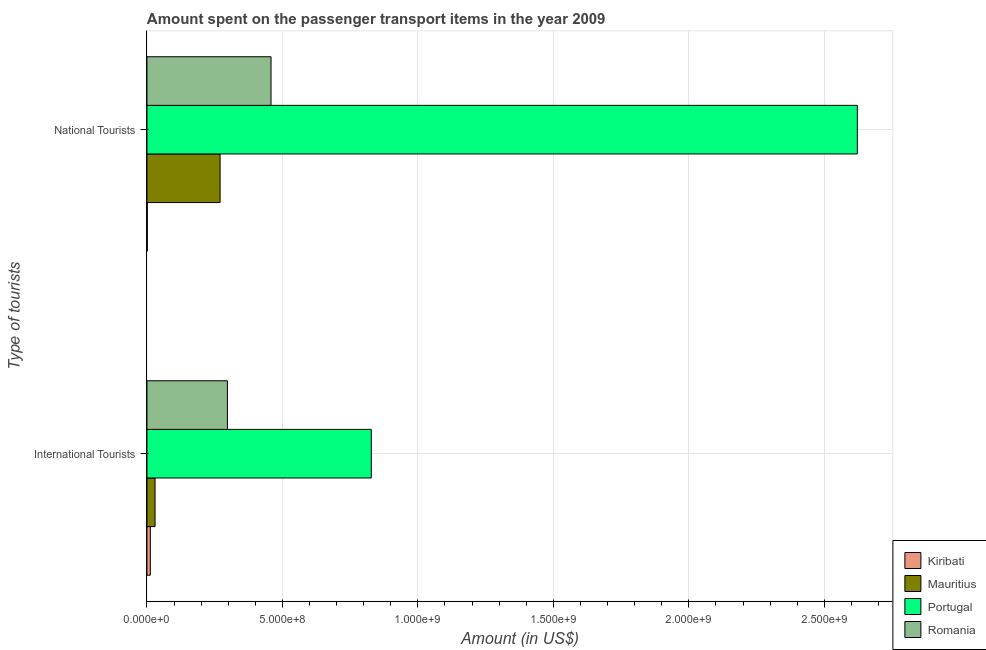Are the number of bars per tick equal to the number of legend labels?
Offer a very short reply. Yes. Are the number of bars on each tick of the Y-axis equal?
Keep it short and to the point. Yes. How many bars are there on the 1st tick from the bottom?
Ensure brevity in your answer.  4. What is the label of the 1st group of bars from the top?
Your response must be concise. National Tourists. What is the amount spent on transport items of international tourists in Mauritius?
Your response must be concise. 3.00e+07. Across all countries, what is the maximum amount spent on transport items of national tourists?
Give a very brief answer. 2.62e+09. Across all countries, what is the minimum amount spent on transport items of national tourists?
Give a very brief answer. 1.30e+06. In which country was the amount spent on transport items of national tourists minimum?
Offer a terse response. Kiribati. What is the total amount spent on transport items of international tourists in the graph?
Your answer should be very brief. 1.17e+09. What is the difference between the amount spent on transport items of international tourists in Romania and that in Portugal?
Provide a short and direct response. -5.31e+08. What is the difference between the amount spent on transport items of national tourists in Romania and the amount spent on transport items of international tourists in Mauritius?
Offer a very short reply. 4.28e+08. What is the average amount spent on transport items of national tourists per country?
Keep it short and to the point. 8.38e+08. What is the difference between the amount spent on transport items of international tourists and amount spent on transport items of national tourists in Romania?
Ensure brevity in your answer.  -1.61e+08. In how many countries, is the amount spent on transport items of national tourists greater than 600000000 US$?
Provide a short and direct response. 1. What is the ratio of the amount spent on transport items of national tourists in Mauritius to that in Romania?
Keep it short and to the point. 0.59. What does the 4th bar from the top in International Tourists represents?
Ensure brevity in your answer.  Kiribati. What does the 1st bar from the bottom in National Tourists represents?
Offer a very short reply. Kiribati. How many bars are there?
Provide a short and direct response. 8. How many countries are there in the graph?
Give a very brief answer. 4. Are the values on the major ticks of X-axis written in scientific E-notation?
Ensure brevity in your answer.  Yes. How are the legend labels stacked?
Your answer should be compact. Vertical. What is the title of the graph?
Offer a very short reply. Amount spent on the passenger transport items in the year 2009. Does "Dominica" appear as one of the legend labels in the graph?
Offer a very short reply. No. What is the label or title of the Y-axis?
Offer a terse response. Type of tourists. What is the Amount (in US$) in Kiribati in International Tourists?
Offer a very short reply. 1.25e+07. What is the Amount (in US$) of Mauritius in International Tourists?
Your answer should be compact. 3.00e+07. What is the Amount (in US$) of Portugal in International Tourists?
Your answer should be compact. 8.28e+08. What is the Amount (in US$) in Romania in International Tourists?
Give a very brief answer. 2.97e+08. What is the Amount (in US$) of Kiribati in National Tourists?
Make the answer very short. 1.30e+06. What is the Amount (in US$) of Mauritius in National Tourists?
Give a very brief answer. 2.70e+08. What is the Amount (in US$) of Portugal in National Tourists?
Your answer should be compact. 2.62e+09. What is the Amount (in US$) in Romania in National Tourists?
Keep it short and to the point. 4.58e+08. Across all Type of tourists, what is the maximum Amount (in US$) in Kiribati?
Keep it short and to the point. 1.25e+07. Across all Type of tourists, what is the maximum Amount (in US$) of Mauritius?
Make the answer very short. 2.70e+08. Across all Type of tourists, what is the maximum Amount (in US$) of Portugal?
Ensure brevity in your answer.  2.62e+09. Across all Type of tourists, what is the maximum Amount (in US$) of Romania?
Make the answer very short. 4.58e+08. Across all Type of tourists, what is the minimum Amount (in US$) of Kiribati?
Keep it short and to the point. 1.30e+06. Across all Type of tourists, what is the minimum Amount (in US$) in Mauritius?
Keep it short and to the point. 3.00e+07. Across all Type of tourists, what is the minimum Amount (in US$) in Portugal?
Make the answer very short. 8.28e+08. Across all Type of tourists, what is the minimum Amount (in US$) in Romania?
Your answer should be compact. 2.97e+08. What is the total Amount (in US$) in Kiribati in the graph?
Your answer should be compact. 1.38e+07. What is the total Amount (in US$) of Mauritius in the graph?
Your response must be concise. 3.00e+08. What is the total Amount (in US$) in Portugal in the graph?
Keep it short and to the point. 3.45e+09. What is the total Amount (in US$) of Romania in the graph?
Offer a very short reply. 7.55e+08. What is the difference between the Amount (in US$) in Kiribati in International Tourists and that in National Tourists?
Offer a terse response. 1.12e+07. What is the difference between the Amount (in US$) of Mauritius in International Tourists and that in National Tourists?
Keep it short and to the point. -2.40e+08. What is the difference between the Amount (in US$) in Portugal in International Tourists and that in National Tourists?
Your response must be concise. -1.79e+09. What is the difference between the Amount (in US$) of Romania in International Tourists and that in National Tourists?
Your answer should be very brief. -1.61e+08. What is the difference between the Amount (in US$) of Kiribati in International Tourists and the Amount (in US$) of Mauritius in National Tourists?
Offer a very short reply. -2.58e+08. What is the difference between the Amount (in US$) in Kiribati in International Tourists and the Amount (in US$) in Portugal in National Tourists?
Keep it short and to the point. -2.61e+09. What is the difference between the Amount (in US$) in Kiribati in International Tourists and the Amount (in US$) in Romania in National Tourists?
Provide a short and direct response. -4.46e+08. What is the difference between the Amount (in US$) of Mauritius in International Tourists and the Amount (in US$) of Portugal in National Tourists?
Your answer should be compact. -2.59e+09. What is the difference between the Amount (in US$) in Mauritius in International Tourists and the Amount (in US$) in Romania in National Tourists?
Provide a short and direct response. -4.28e+08. What is the difference between the Amount (in US$) in Portugal in International Tourists and the Amount (in US$) in Romania in National Tourists?
Ensure brevity in your answer.  3.70e+08. What is the average Amount (in US$) in Kiribati per Type of tourists?
Your answer should be compact. 6.90e+06. What is the average Amount (in US$) in Mauritius per Type of tourists?
Offer a terse response. 1.50e+08. What is the average Amount (in US$) of Portugal per Type of tourists?
Provide a short and direct response. 1.72e+09. What is the average Amount (in US$) of Romania per Type of tourists?
Offer a terse response. 3.78e+08. What is the difference between the Amount (in US$) in Kiribati and Amount (in US$) in Mauritius in International Tourists?
Your answer should be compact. -1.75e+07. What is the difference between the Amount (in US$) of Kiribati and Amount (in US$) of Portugal in International Tourists?
Make the answer very short. -8.16e+08. What is the difference between the Amount (in US$) of Kiribati and Amount (in US$) of Romania in International Tourists?
Your response must be concise. -2.84e+08. What is the difference between the Amount (in US$) of Mauritius and Amount (in US$) of Portugal in International Tourists?
Your answer should be very brief. -7.98e+08. What is the difference between the Amount (in US$) in Mauritius and Amount (in US$) in Romania in International Tourists?
Make the answer very short. -2.67e+08. What is the difference between the Amount (in US$) in Portugal and Amount (in US$) in Romania in International Tourists?
Your answer should be compact. 5.31e+08. What is the difference between the Amount (in US$) of Kiribati and Amount (in US$) of Mauritius in National Tourists?
Your answer should be very brief. -2.69e+08. What is the difference between the Amount (in US$) of Kiribati and Amount (in US$) of Portugal in National Tourists?
Ensure brevity in your answer.  -2.62e+09. What is the difference between the Amount (in US$) in Kiribati and Amount (in US$) in Romania in National Tourists?
Keep it short and to the point. -4.57e+08. What is the difference between the Amount (in US$) in Mauritius and Amount (in US$) in Portugal in National Tourists?
Give a very brief answer. -2.35e+09. What is the difference between the Amount (in US$) in Mauritius and Amount (in US$) in Romania in National Tourists?
Your response must be concise. -1.88e+08. What is the difference between the Amount (in US$) of Portugal and Amount (in US$) of Romania in National Tourists?
Keep it short and to the point. 2.16e+09. What is the ratio of the Amount (in US$) of Kiribati in International Tourists to that in National Tourists?
Provide a short and direct response. 9.62. What is the ratio of the Amount (in US$) of Mauritius in International Tourists to that in National Tourists?
Provide a succinct answer. 0.11. What is the ratio of the Amount (in US$) in Portugal in International Tourists to that in National Tourists?
Provide a succinct answer. 0.32. What is the ratio of the Amount (in US$) of Romania in International Tourists to that in National Tourists?
Keep it short and to the point. 0.65. What is the difference between the highest and the second highest Amount (in US$) of Kiribati?
Offer a very short reply. 1.12e+07. What is the difference between the highest and the second highest Amount (in US$) in Mauritius?
Offer a terse response. 2.40e+08. What is the difference between the highest and the second highest Amount (in US$) of Portugal?
Ensure brevity in your answer.  1.79e+09. What is the difference between the highest and the second highest Amount (in US$) in Romania?
Make the answer very short. 1.61e+08. What is the difference between the highest and the lowest Amount (in US$) of Kiribati?
Provide a short and direct response. 1.12e+07. What is the difference between the highest and the lowest Amount (in US$) in Mauritius?
Provide a short and direct response. 2.40e+08. What is the difference between the highest and the lowest Amount (in US$) of Portugal?
Give a very brief answer. 1.79e+09. What is the difference between the highest and the lowest Amount (in US$) of Romania?
Give a very brief answer. 1.61e+08. 